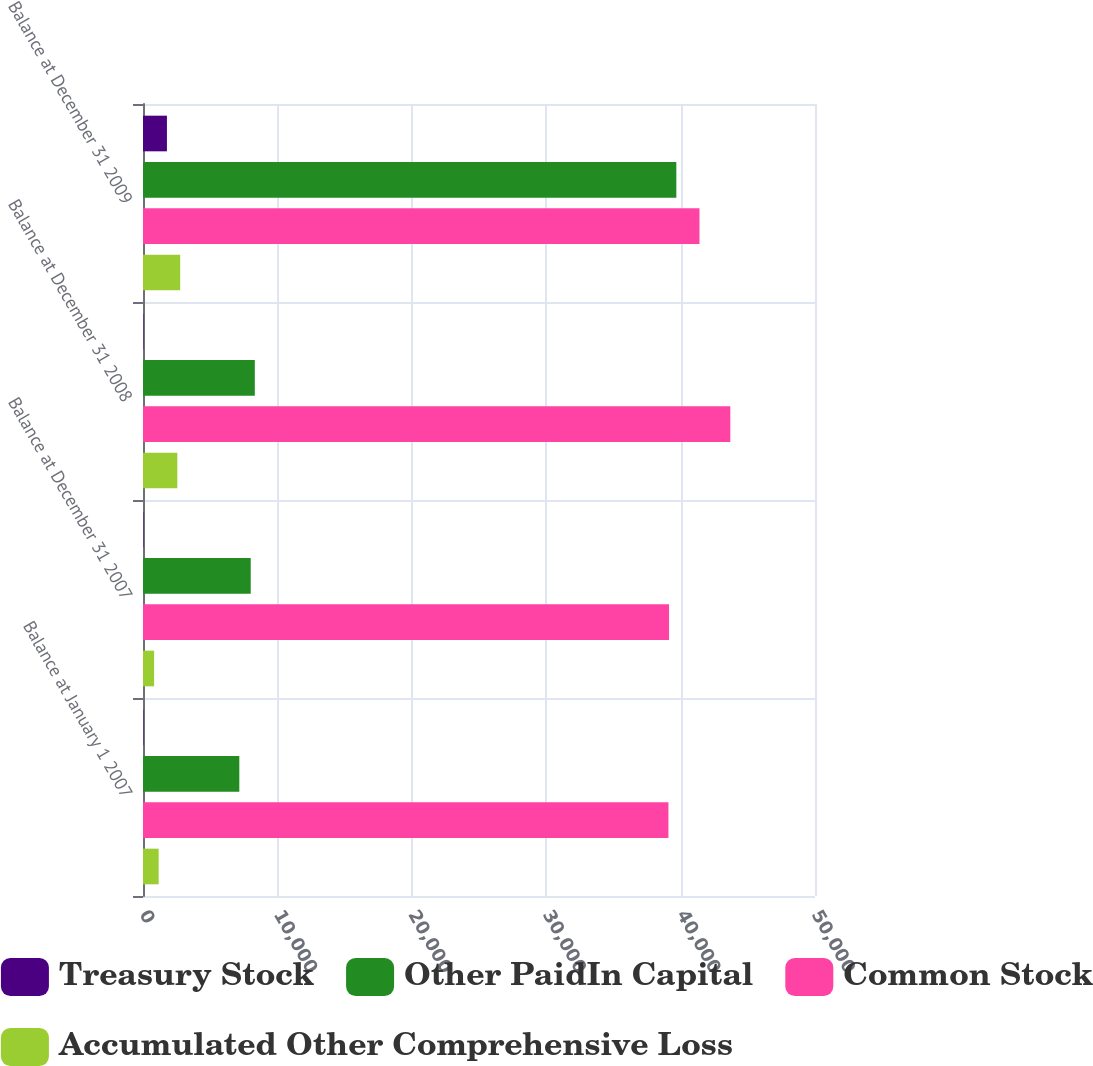Convert chart. <chart><loc_0><loc_0><loc_500><loc_500><stacked_bar_chart><ecel><fcel>Balance at January 1 2007<fcel>Balance at December 31 2007<fcel>Balance at December 31 2008<fcel>Balance at December 31 2009<nl><fcel>Treasury Stock<fcel>29.8<fcel>29.8<fcel>29.8<fcel>1781.3<nl><fcel>Other PaidIn Capital<fcel>7166.5<fcel>8014.9<fcel>8319.1<fcel>39682.6<nl><fcel>Common Stock<fcel>39095.1<fcel>39140.8<fcel>43698.8<fcel>41404.9<nl><fcel>Accumulated Other Comprehensive Loss<fcel>1164.3<fcel>826.1<fcel>2553.9<fcel>2766.5<nl></chart> 